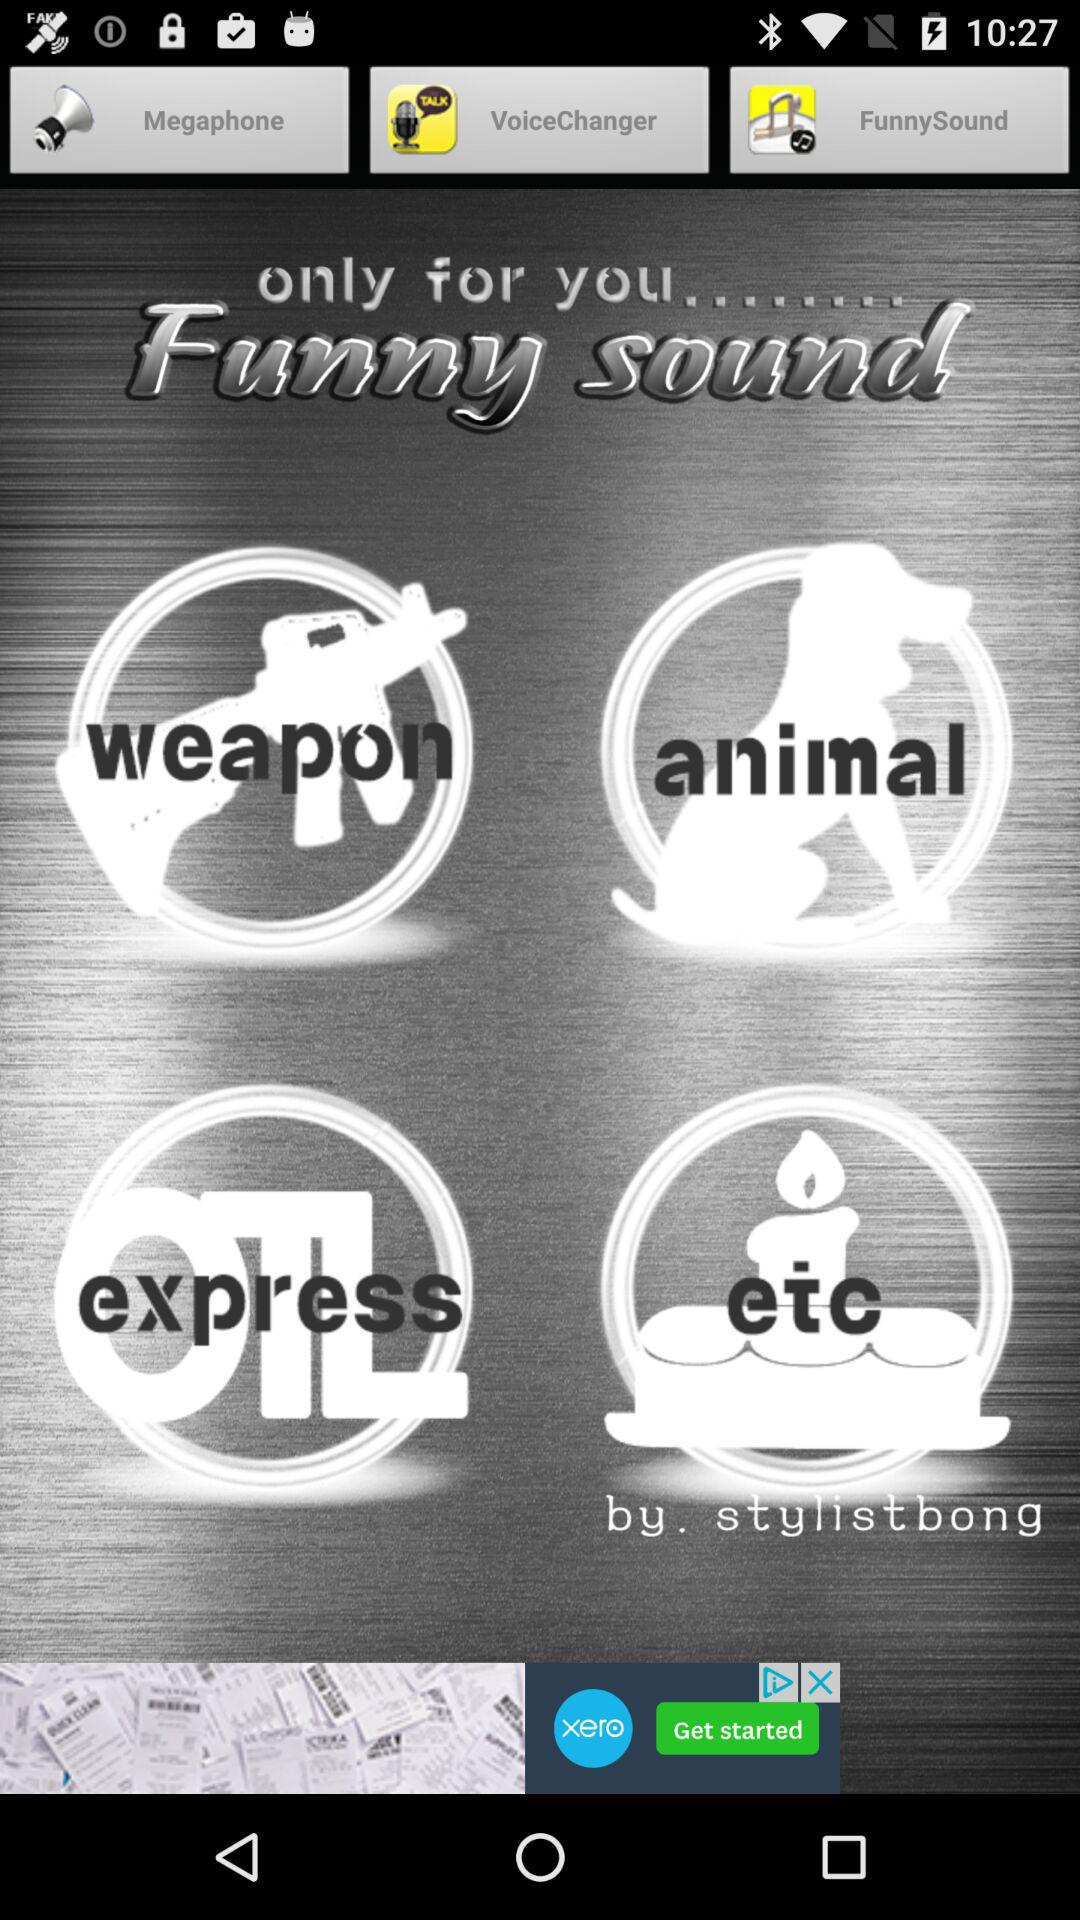What is the name of the application? The name of the application is "Megaphone". 